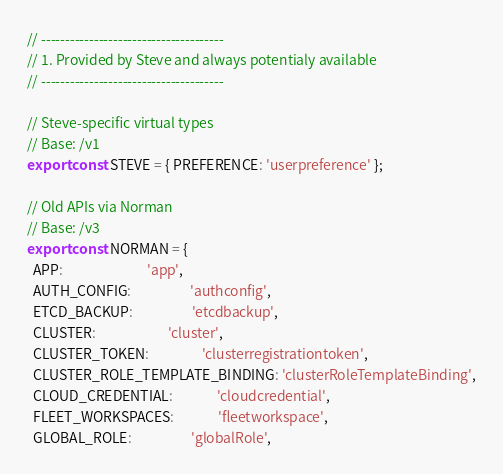<code> <loc_0><loc_0><loc_500><loc_500><_JavaScript_>// --------------------------------------
// 1. Provided by Steve and always potentialy available
// --------------------------------------

// Steve-specific virtual types
// Base: /v1
export const STEVE = { PREFERENCE: 'userpreference' };

// Old APIs via Norman
// Base: /v3
export const NORMAN = {
  APP:                           'app',
  AUTH_CONFIG:                   'authconfig',
  ETCD_BACKUP:                   'etcdbackup',
  CLUSTER:                       'cluster',
  CLUSTER_TOKEN:                 'clusterregistrationtoken',
  CLUSTER_ROLE_TEMPLATE_BINDING: 'clusterRoleTemplateBinding',
  CLOUD_CREDENTIAL:              'cloudcredential',
  FLEET_WORKSPACES:              'fleetworkspace',
  GLOBAL_ROLE:                   'globalRole',</code> 